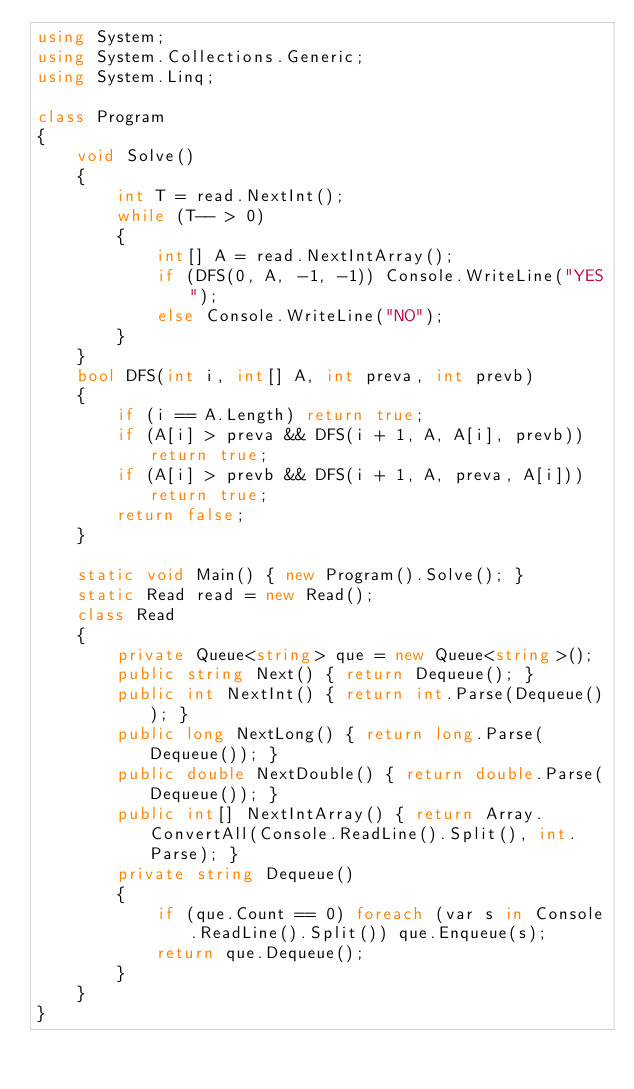<code> <loc_0><loc_0><loc_500><loc_500><_C#_>using System;
using System.Collections.Generic;
using System.Linq;

class Program
{
    void Solve()
    {
        int T = read.NextInt();
        while (T-- > 0)
        {
            int[] A = read.NextIntArray();
            if (DFS(0, A, -1, -1)) Console.WriteLine("YES");
            else Console.WriteLine("NO");
        }
    }
    bool DFS(int i, int[] A, int preva, int prevb)
    {
        if (i == A.Length) return true;
        if (A[i] > preva && DFS(i + 1, A, A[i], prevb)) return true;
        if (A[i] > prevb && DFS(i + 1, A, preva, A[i])) return true;
        return false;
    }

    static void Main() { new Program().Solve(); }
    static Read read = new Read();
    class Read
    {
        private Queue<string> que = new Queue<string>();
        public string Next() { return Dequeue(); }
        public int NextInt() { return int.Parse(Dequeue()); }
        public long NextLong() { return long.Parse(Dequeue()); }
        public double NextDouble() { return double.Parse(Dequeue()); }
        public int[] NextIntArray() { return Array.ConvertAll(Console.ReadLine().Split(), int.Parse); }
        private string Dequeue()
        {
            if (que.Count == 0) foreach (var s in Console.ReadLine().Split()) que.Enqueue(s);
            return que.Dequeue();
        }
    }
}</code> 